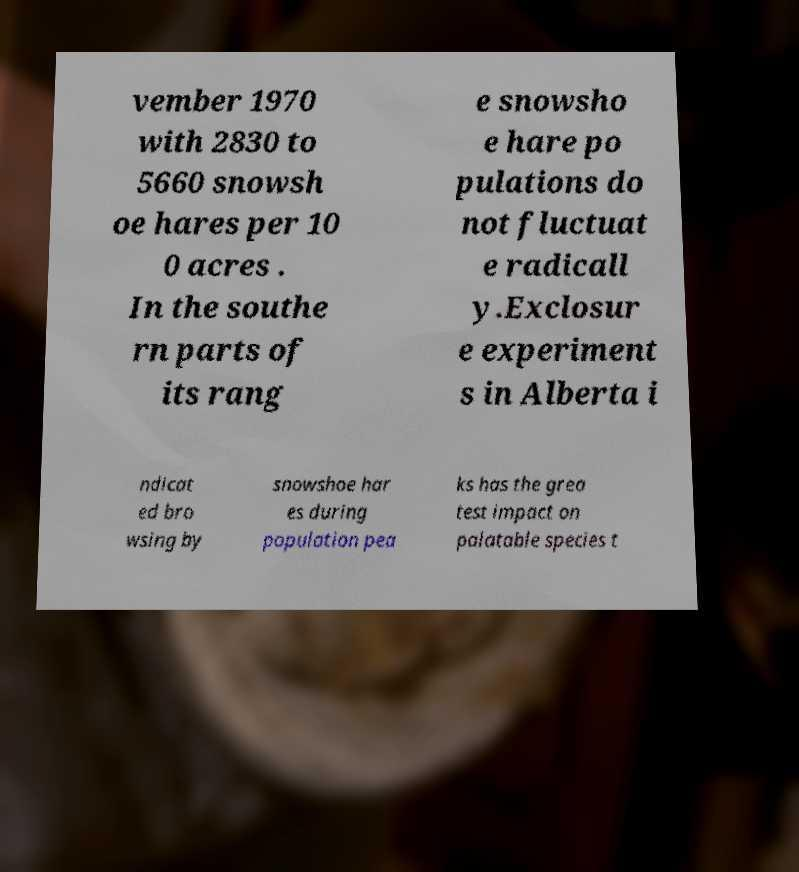Can you read and provide the text displayed in the image?This photo seems to have some interesting text. Can you extract and type it out for me? vember 1970 with 2830 to 5660 snowsh oe hares per 10 0 acres . In the southe rn parts of its rang e snowsho e hare po pulations do not fluctuat e radicall y.Exclosur e experiment s in Alberta i ndicat ed bro wsing by snowshoe har es during population pea ks has the grea test impact on palatable species t 